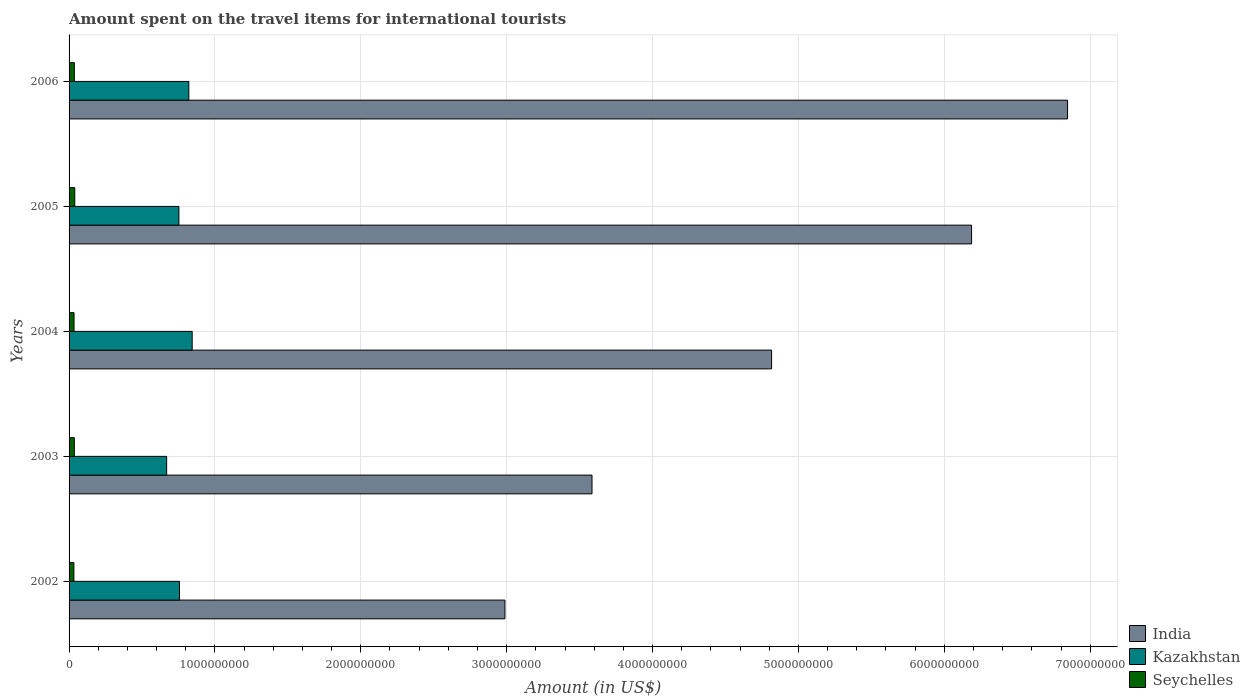What is the label of the 2nd group of bars from the top?
Make the answer very short. 2005. What is the amount spent on the travel items for international tourists in Seychelles in 2006?
Provide a short and direct response. 3.60e+07. Across all years, what is the maximum amount spent on the travel items for international tourists in India?
Give a very brief answer. 6.84e+09. Across all years, what is the minimum amount spent on the travel items for international tourists in India?
Your response must be concise. 2.99e+09. In which year was the amount spent on the travel items for international tourists in Seychelles maximum?
Give a very brief answer. 2005. In which year was the amount spent on the travel items for international tourists in Seychelles minimum?
Make the answer very short. 2002. What is the total amount spent on the travel items for international tourists in India in the graph?
Your answer should be compact. 2.44e+1. What is the difference between the amount spent on the travel items for international tourists in Seychelles in 2003 and that in 2006?
Provide a short and direct response. 0. What is the difference between the amount spent on the travel items for international tourists in India in 2004 and the amount spent on the travel items for international tourists in Kazakhstan in 2003?
Your answer should be compact. 4.15e+09. What is the average amount spent on the travel items for international tourists in Kazakhstan per year?
Provide a short and direct response. 7.69e+08. In the year 2002, what is the difference between the amount spent on the travel items for international tourists in Seychelles and amount spent on the travel items for international tourists in India?
Your response must be concise. -2.96e+09. What is the ratio of the amount spent on the travel items for international tourists in India in 2002 to that in 2003?
Give a very brief answer. 0.83. What is the difference between the highest and the lowest amount spent on the travel items for international tourists in Seychelles?
Offer a terse response. 6.00e+06. What does the 3rd bar from the bottom in 2003 represents?
Your answer should be compact. Seychelles. Is it the case that in every year, the sum of the amount spent on the travel items for international tourists in Seychelles and amount spent on the travel items for international tourists in Kazakhstan is greater than the amount spent on the travel items for international tourists in India?
Your answer should be compact. No. How many bars are there?
Your answer should be very brief. 15. Are all the bars in the graph horizontal?
Your answer should be compact. Yes. Does the graph contain any zero values?
Keep it short and to the point. No. How are the legend labels stacked?
Your answer should be compact. Vertical. What is the title of the graph?
Provide a short and direct response. Amount spent on the travel items for international tourists. Does "Micronesia" appear as one of the legend labels in the graph?
Your response must be concise. No. What is the label or title of the X-axis?
Give a very brief answer. Amount (in US$). What is the label or title of the Y-axis?
Your answer should be very brief. Years. What is the Amount (in US$) in India in 2002?
Offer a terse response. 2.99e+09. What is the Amount (in US$) in Kazakhstan in 2002?
Keep it short and to the point. 7.57e+08. What is the Amount (in US$) of Seychelles in 2002?
Provide a succinct answer. 3.30e+07. What is the Amount (in US$) in India in 2003?
Your response must be concise. 3.58e+09. What is the Amount (in US$) of Kazakhstan in 2003?
Offer a terse response. 6.69e+08. What is the Amount (in US$) in Seychelles in 2003?
Your answer should be compact. 3.60e+07. What is the Amount (in US$) of India in 2004?
Provide a short and direct response. 4.82e+09. What is the Amount (in US$) in Kazakhstan in 2004?
Ensure brevity in your answer.  8.44e+08. What is the Amount (in US$) of Seychelles in 2004?
Ensure brevity in your answer.  3.40e+07. What is the Amount (in US$) in India in 2005?
Your response must be concise. 6.19e+09. What is the Amount (in US$) of Kazakhstan in 2005?
Make the answer very short. 7.53e+08. What is the Amount (in US$) in Seychelles in 2005?
Keep it short and to the point. 3.90e+07. What is the Amount (in US$) in India in 2006?
Provide a succinct answer. 6.84e+09. What is the Amount (in US$) of Kazakhstan in 2006?
Ensure brevity in your answer.  8.21e+08. What is the Amount (in US$) of Seychelles in 2006?
Provide a succinct answer. 3.60e+07. Across all years, what is the maximum Amount (in US$) of India?
Make the answer very short. 6.84e+09. Across all years, what is the maximum Amount (in US$) in Kazakhstan?
Your answer should be very brief. 8.44e+08. Across all years, what is the maximum Amount (in US$) of Seychelles?
Offer a very short reply. 3.90e+07. Across all years, what is the minimum Amount (in US$) of India?
Give a very brief answer. 2.99e+09. Across all years, what is the minimum Amount (in US$) of Kazakhstan?
Provide a succinct answer. 6.69e+08. Across all years, what is the minimum Amount (in US$) in Seychelles?
Your answer should be compact. 3.30e+07. What is the total Amount (in US$) of India in the graph?
Offer a terse response. 2.44e+1. What is the total Amount (in US$) in Kazakhstan in the graph?
Offer a very short reply. 3.84e+09. What is the total Amount (in US$) in Seychelles in the graph?
Keep it short and to the point. 1.78e+08. What is the difference between the Amount (in US$) of India in 2002 and that in 2003?
Offer a terse response. -5.97e+08. What is the difference between the Amount (in US$) in Kazakhstan in 2002 and that in 2003?
Make the answer very short. 8.80e+07. What is the difference between the Amount (in US$) in Seychelles in 2002 and that in 2003?
Offer a terse response. -3.00e+06. What is the difference between the Amount (in US$) of India in 2002 and that in 2004?
Your response must be concise. -1.83e+09. What is the difference between the Amount (in US$) of Kazakhstan in 2002 and that in 2004?
Offer a terse response. -8.70e+07. What is the difference between the Amount (in US$) of Seychelles in 2002 and that in 2004?
Your response must be concise. -1.00e+06. What is the difference between the Amount (in US$) of India in 2002 and that in 2005?
Your response must be concise. -3.20e+09. What is the difference between the Amount (in US$) in Kazakhstan in 2002 and that in 2005?
Your answer should be compact. 4.00e+06. What is the difference between the Amount (in US$) in Seychelles in 2002 and that in 2005?
Provide a succinct answer. -6.00e+06. What is the difference between the Amount (in US$) of India in 2002 and that in 2006?
Your response must be concise. -3.86e+09. What is the difference between the Amount (in US$) in Kazakhstan in 2002 and that in 2006?
Make the answer very short. -6.40e+07. What is the difference between the Amount (in US$) of Seychelles in 2002 and that in 2006?
Offer a terse response. -3.00e+06. What is the difference between the Amount (in US$) in India in 2003 and that in 2004?
Your response must be concise. -1.23e+09. What is the difference between the Amount (in US$) in Kazakhstan in 2003 and that in 2004?
Keep it short and to the point. -1.75e+08. What is the difference between the Amount (in US$) in Seychelles in 2003 and that in 2004?
Provide a short and direct response. 2.00e+06. What is the difference between the Amount (in US$) of India in 2003 and that in 2005?
Provide a succinct answer. -2.60e+09. What is the difference between the Amount (in US$) of Kazakhstan in 2003 and that in 2005?
Provide a succinct answer. -8.40e+07. What is the difference between the Amount (in US$) of India in 2003 and that in 2006?
Make the answer very short. -3.26e+09. What is the difference between the Amount (in US$) of Kazakhstan in 2003 and that in 2006?
Provide a short and direct response. -1.52e+08. What is the difference between the Amount (in US$) in Seychelles in 2003 and that in 2006?
Provide a short and direct response. 0. What is the difference between the Amount (in US$) of India in 2004 and that in 2005?
Provide a succinct answer. -1.37e+09. What is the difference between the Amount (in US$) of Kazakhstan in 2004 and that in 2005?
Your response must be concise. 9.10e+07. What is the difference between the Amount (in US$) of Seychelles in 2004 and that in 2005?
Make the answer very short. -5.00e+06. What is the difference between the Amount (in US$) of India in 2004 and that in 2006?
Offer a terse response. -2.03e+09. What is the difference between the Amount (in US$) in Kazakhstan in 2004 and that in 2006?
Provide a succinct answer. 2.30e+07. What is the difference between the Amount (in US$) in India in 2005 and that in 2006?
Your answer should be compact. -6.58e+08. What is the difference between the Amount (in US$) in Kazakhstan in 2005 and that in 2006?
Keep it short and to the point. -6.80e+07. What is the difference between the Amount (in US$) in Seychelles in 2005 and that in 2006?
Give a very brief answer. 3.00e+06. What is the difference between the Amount (in US$) in India in 2002 and the Amount (in US$) in Kazakhstan in 2003?
Make the answer very short. 2.32e+09. What is the difference between the Amount (in US$) in India in 2002 and the Amount (in US$) in Seychelles in 2003?
Ensure brevity in your answer.  2.95e+09. What is the difference between the Amount (in US$) in Kazakhstan in 2002 and the Amount (in US$) in Seychelles in 2003?
Offer a very short reply. 7.21e+08. What is the difference between the Amount (in US$) in India in 2002 and the Amount (in US$) in Kazakhstan in 2004?
Provide a succinct answer. 2.14e+09. What is the difference between the Amount (in US$) of India in 2002 and the Amount (in US$) of Seychelles in 2004?
Keep it short and to the point. 2.95e+09. What is the difference between the Amount (in US$) of Kazakhstan in 2002 and the Amount (in US$) of Seychelles in 2004?
Offer a very short reply. 7.23e+08. What is the difference between the Amount (in US$) in India in 2002 and the Amount (in US$) in Kazakhstan in 2005?
Keep it short and to the point. 2.24e+09. What is the difference between the Amount (in US$) of India in 2002 and the Amount (in US$) of Seychelles in 2005?
Your answer should be compact. 2.95e+09. What is the difference between the Amount (in US$) of Kazakhstan in 2002 and the Amount (in US$) of Seychelles in 2005?
Your answer should be compact. 7.18e+08. What is the difference between the Amount (in US$) of India in 2002 and the Amount (in US$) of Kazakhstan in 2006?
Provide a short and direct response. 2.17e+09. What is the difference between the Amount (in US$) of India in 2002 and the Amount (in US$) of Seychelles in 2006?
Your answer should be compact. 2.95e+09. What is the difference between the Amount (in US$) in Kazakhstan in 2002 and the Amount (in US$) in Seychelles in 2006?
Your answer should be very brief. 7.21e+08. What is the difference between the Amount (in US$) in India in 2003 and the Amount (in US$) in Kazakhstan in 2004?
Keep it short and to the point. 2.74e+09. What is the difference between the Amount (in US$) of India in 2003 and the Amount (in US$) of Seychelles in 2004?
Offer a terse response. 3.55e+09. What is the difference between the Amount (in US$) in Kazakhstan in 2003 and the Amount (in US$) in Seychelles in 2004?
Make the answer very short. 6.35e+08. What is the difference between the Amount (in US$) in India in 2003 and the Amount (in US$) in Kazakhstan in 2005?
Ensure brevity in your answer.  2.83e+09. What is the difference between the Amount (in US$) of India in 2003 and the Amount (in US$) of Seychelles in 2005?
Provide a succinct answer. 3.55e+09. What is the difference between the Amount (in US$) in Kazakhstan in 2003 and the Amount (in US$) in Seychelles in 2005?
Offer a very short reply. 6.30e+08. What is the difference between the Amount (in US$) of India in 2003 and the Amount (in US$) of Kazakhstan in 2006?
Make the answer very short. 2.76e+09. What is the difference between the Amount (in US$) in India in 2003 and the Amount (in US$) in Seychelles in 2006?
Make the answer very short. 3.55e+09. What is the difference between the Amount (in US$) in Kazakhstan in 2003 and the Amount (in US$) in Seychelles in 2006?
Make the answer very short. 6.33e+08. What is the difference between the Amount (in US$) of India in 2004 and the Amount (in US$) of Kazakhstan in 2005?
Offer a very short reply. 4.06e+09. What is the difference between the Amount (in US$) of India in 2004 and the Amount (in US$) of Seychelles in 2005?
Make the answer very short. 4.78e+09. What is the difference between the Amount (in US$) in Kazakhstan in 2004 and the Amount (in US$) in Seychelles in 2005?
Offer a very short reply. 8.05e+08. What is the difference between the Amount (in US$) of India in 2004 and the Amount (in US$) of Kazakhstan in 2006?
Provide a succinct answer. 4.00e+09. What is the difference between the Amount (in US$) of India in 2004 and the Amount (in US$) of Seychelles in 2006?
Offer a very short reply. 4.78e+09. What is the difference between the Amount (in US$) of Kazakhstan in 2004 and the Amount (in US$) of Seychelles in 2006?
Provide a succinct answer. 8.08e+08. What is the difference between the Amount (in US$) in India in 2005 and the Amount (in US$) in Kazakhstan in 2006?
Make the answer very short. 5.37e+09. What is the difference between the Amount (in US$) of India in 2005 and the Amount (in US$) of Seychelles in 2006?
Your response must be concise. 6.15e+09. What is the difference between the Amount (in US$) of Kazakhstan in 2005 and the Amount (in US$) of Seychelles in 2006?
Make the answer very short. 7.17e+08. What is the average Amount (in US$) of India per year?
Your response must be concise. 4.88e+09. What is the average Amount (in US$) of Kazakhstan per year?
Your response must be concise. 7.69e+08. What is the average Amount (in US$) of Seychelles per year?
Provide a succinct answer. 3.56e+07. In the year 2002, what is the difference between the Amount (in US$) in India and Amount (in US$) in Kazakhstan?
Give a very brief answer. 2.23e+09. In the year 2002, what is the difference between the Amount (in US$) in India and Amount (in US$) in Seychelles?
Provide a short and direct response. 2.96e+09. In the year 2002, what is the difference between the Amount (in US$) in Kazakhstan and Amount (in US$) in Seychelles?
Provide a succinct answer. 7.24e+08. In the year 2003, what is the difference between the Amount (in US$) in India and Amount (in US$) in Kazakhstan?
Your answer should be compact. 2.92e+09. In the year 2003, what is the difference between the Amount (in US$) in India and Amount (in US$) in Seychelles?
Make the answer very short. 3.55e+09. In the year 2003, what is the difference between the Amount (in US$) in Kazakhstan and Amount (in US$) in Seychelles?
Your answer should be very brief. 6.33e+08. In the year 2004, what is the difference between the Amount (in US$) in India and Amount (in US$) in Kazakhstan?
Offer a terse response. 3.97e+09. In the year 2004, what is the difference between the Amount (in US$) in India and Amount (in US$) in Seychelles?
Your response must be concise. 4.78e+09. In the year 2004, what is the difference between the Amount (in US$) in Kazakhstan and Amount (in US$) in Seychelles?
Keep it short and to the point. 8.10e+08. In the year 2005, what is the difference between the Amount (in US$) of India and Amount (in US$) of Kazakhstan?
Keep it short and to the point. 5.43e+09. In the year 2005, what is the difference between the Amount (in US$) in India and Amount (in US$) in Seychelles?
Make the answer very short. 6.15e+09. In the year 2005, what is the difference between the Amount (in US$) in Kazakhstan and Amount (in US$) in Seychelles?
Offer a very short reply. 7.14e+08. In the year 2006, what is the difference between the Amount (in US$) of India and Amount (in US$) of Kazakhstan?
Make the answer very short. 6.02e+09. In the year 2006, what is the difference between the Amount (in US$) in India and Amount (in US$) in Seychelles?
Your response must be concise. 6.81e+09. In the year 2006, what is the difference between the Amount (in US$) in Kazakhstan and Amount (in US$) in Seychelles?
Make the answer very short. 7.85e+08. What is the ratio of the Amount (in US$) of India in 2002 to that in 2003?
Provide a succinct answer. 0.83. What is the ratio of the Amount (in US$) of Kazakhstan in 2002 to that in 2003?
Offer a terse response. 1.13. What is the ratio of the Amount (in US$) in Seychelles in 2002 to that in 2003?
Give a very brief answer. 0.92. What is the ratio of the Amount (in US$) of India in 2002 to that in 2004?
Your answer should be very brief. 0.62. What is the ratio of the Amount (in US$) in Kazakhstan in 2002 to that in 2004?
Offer a terse response. 0.9. What is the ratio of the Amount (in US$) in Seychelles in 2002 to that in 2004?
Ensure brevity in your answer.  0.97. What is the ratio of the Amount (in US$) in India in 2002 to that in 2005?
Ensure brevity in your answer.  0.48. What is the ratio of the Amount (in US$) in Seychelles in 2002 to that in 2005?
Offer a very short reply. 0.85. What is the ratio of the Amount (in US$) in India in 2002 to that in 2006?
Your answer should be very brief. 0.44. What is the ratio of the Amount (in US$) of Kazakhstan in 2002 to that in 2006?
Offer a terse response. 0.92. What is the ratio of the Amount (in US$) of India in 2003 to that in 2004?
Your response must be concise. 0.74. What is the ratio of the Amount (in US$) in Kazakhstan in 2003 to that in 2004?
Offer a terse response. 0.79. What is the ratio of the Amount (in US$) in Seychelles in 2003 to that in 2004?
Offer a terse response. 1.06. What is the ratio of the Amount (in US$) in India in 2003 to that in 2005?
Ensure brevity in your answer.  0.58. What is the ratio of the Amount (in US$) of Kazakhstan in 2003 to that in 2005?
Ensure brevity in your answer.  0.89. What is the ratio of the Amount (in US$) of Seychelles in 2003 to that in 2005?
Make the answer very short. 0.92. What is the ratio of the Amount (in US$) in India in 2003 to that in 2006?
Offer a very short reply. 0.52. What is the ratio of the Amount (in US$) in Kazakhstan in 2003 to that in 2006?
Your answer should be compact. 0.81. What is the ratio of the Amount (in US$) of India in 2004 to that in 2005?
Provide a succinct answer. 0.78. What is the ratio of the Amount (in US$) in Kazakhstan in 2004 to that in 2005?
Provide a short and direct response. 1.12. What is the ratio of the Amount (in US$) of Seychelles in 2004 to that in 2005?
Your response must be concise. 0.87. What is the ratio of the Amount (in US$) in India in 2004 to that in 2006?
Your answer should be compact. 0.7. What is the ratio of the Amount (in US$) in Kazakhstan in 2004 to that in 2006?
Your response must be concise. 1.03. What is the ratio of the Amount (in US$) in India in 2005 to that in 2006?
Provide a succinct answer. 0.9. What is the ratio of the Amount (in US$) of Kazakhstan in 2005 to that in 2006?
Your answer should be compact. 0.92. What is the ratio of the Amount (in US$) of Seychelles in 2005 to that in 2006?
Give a very brief answer. 1.08. What is the difference between the highest and the second highest Amount (in US$) of India?
Provide a succinct answer. 6.58e+08. What is the difference between the highest and the second highest Amount (in US$) in Kazakhstan?
Make the answer very short. 2.30e+07. What is the difference between the highest and the lowest Amount (in US$) of India?
Make the answer very short. 3.86e+09. What is the difference between the highest and the lowest Amount (in US$) of Kazakhstan?
Give a very brief answer. 1.75e+08. What is the difference between the highest and the lowest Amount (in US$) of Seychelles?
Offer a very short reply. 6.00e+06. 